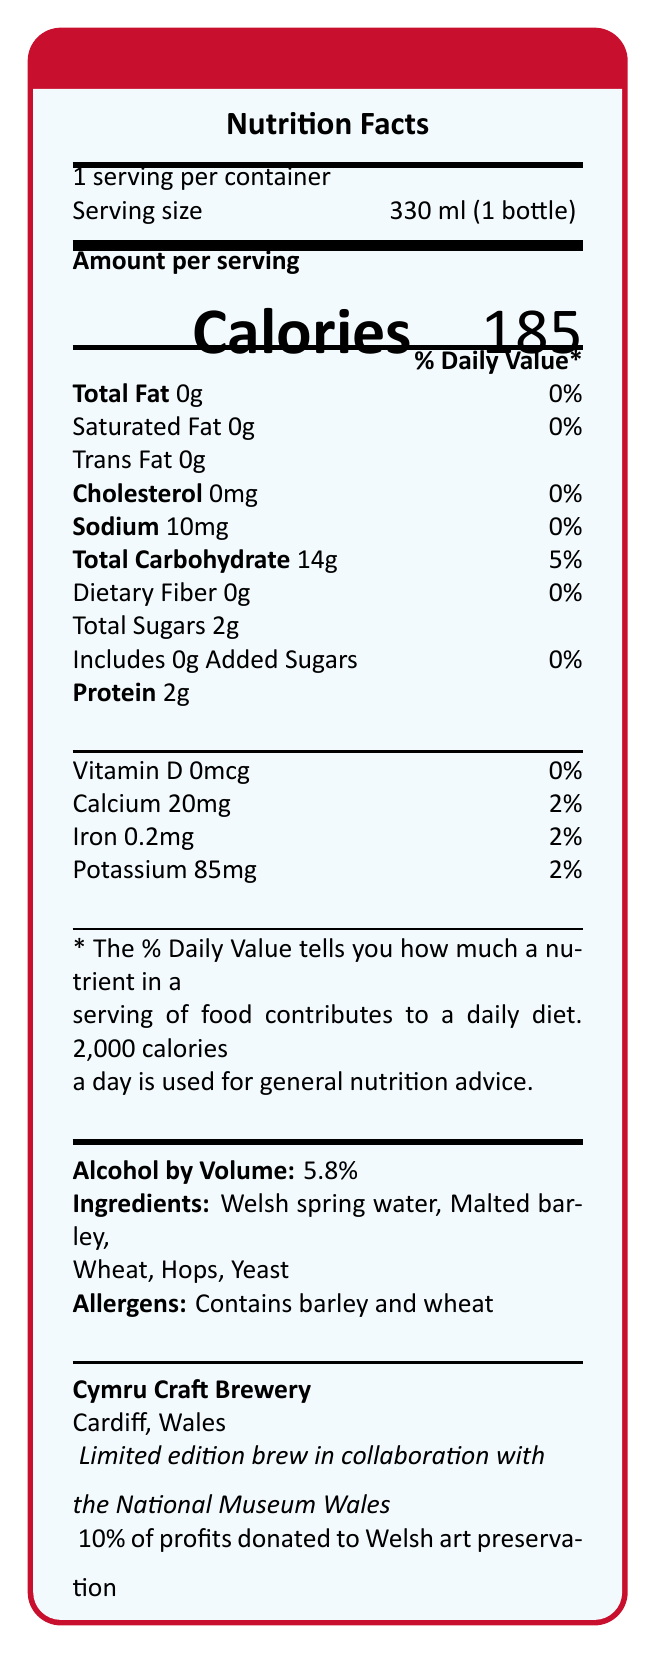what is the serving size for Anderson's Dreamscape Ale? The serving size is explicitly listed as 330 ml (1 bottle) in the document.
Answer: 330 ml (1 bottle) how many calories are in a single serving of Anderson's Dreamscape Ale? The document shows that there are 185 calories per serving.
Answer: 185 what percentage of profits from Anderson's Dreamscape Ale is donated to Welsh art preservation? The document states that 10% of profits are donated to Welsh art preservation.
Answer: 10% what is the total carbohydrate content in Anderson's Dreamscape Ale? The document lists the total carbohydrate content as 14g.
Answer: 14g which ingredients are used in Anderson's Dreamscape Ale? The ingredients are clearly listed in the document as Welsh spring water, Malted barley, Wheat, Hops, and Yeast.
Answer: Welsh spring water, Malted barley, Wheat, Hops, Yeast what is unique about the bottle manufacturing of Anderson's Dreamscape Ale? A. Made from 100% recycled glass B. Made from 50% recycled glass C. Made from 75% recycled glass D. Made from new glass The document mentions that the bottle is made from 50% recycled glass.
Answer: B where is the brewery that produces Anderson's Dreamscape Ale located? A. Swansea, Wales B. Cardiff, Wales C. Newport, Wales D. Wrexham, Wales The brewery location is specified as Cardiff, Wales.
Answer: B what are the tasting notes of Anderson's Dreamscape Ale? A. Hints of local heather, Subtle citrus undertones, Smooth malty finish B. Fruity, Spicy, Woody C. Floral, Earthy, Sweet D. Bitter, Nutty, Smoky The document describes the tasting notes as hints of local heather, subtle citrus undertones, and a smooth malty finish.
Answer: A is Anderson's Dreamscape Ale a limited edition brew? The document states that it is a limited edition brew.
Answer: Yes does Anderson's Dreamscape Ale contain any allergens? The document indicates it contains barley and wheat, which are allergens.
Answer: Yes what is the main idea of the document? The document describes various aspects of Anderson's Dreamscape Ale, highlighting its nutritional content, ingredients, and special features.
Answer: The document provides detailed information about Anderson's Dreamscape Ale, a limited edition Welsh craft beer brewed by Cymru Craft Brewery in collaboration with the National Museum Wales. It includes nutritional facts, ingredients, allergens, tasting notes, and information about charitable contributions and sustainability. what is the total fat content in Anderson's Dreamscape Ale? The document lists the total fat content as 0g.
Answer: 0g how many grams of added sugars are in Anderson's Dreamscape Ale? The document states that there are 0g of added sugars.
Answer: 0g what vitamin content is included in Anderson's Dreamscape Ale? The document specifies that the beer contains 0mcg of Vitamin D.
Answer: Vitamin D 0mcg which food pairing suggestions are provided for Anderson's Dreamscape Ale? The document suggests pairing the ale with Welsh rarebit, lamb cawl, and Caerphilly cheese.
Answer: Welsh rarebit, Lamb cawl, Caerphilly cheese who created the label artwork for Anderson's Dreamscape Ale? The document mentions the label features Anderson's 'Welsh Landscape' painting but does not specify who created the label artwork.
Answer: Cannot be determined 